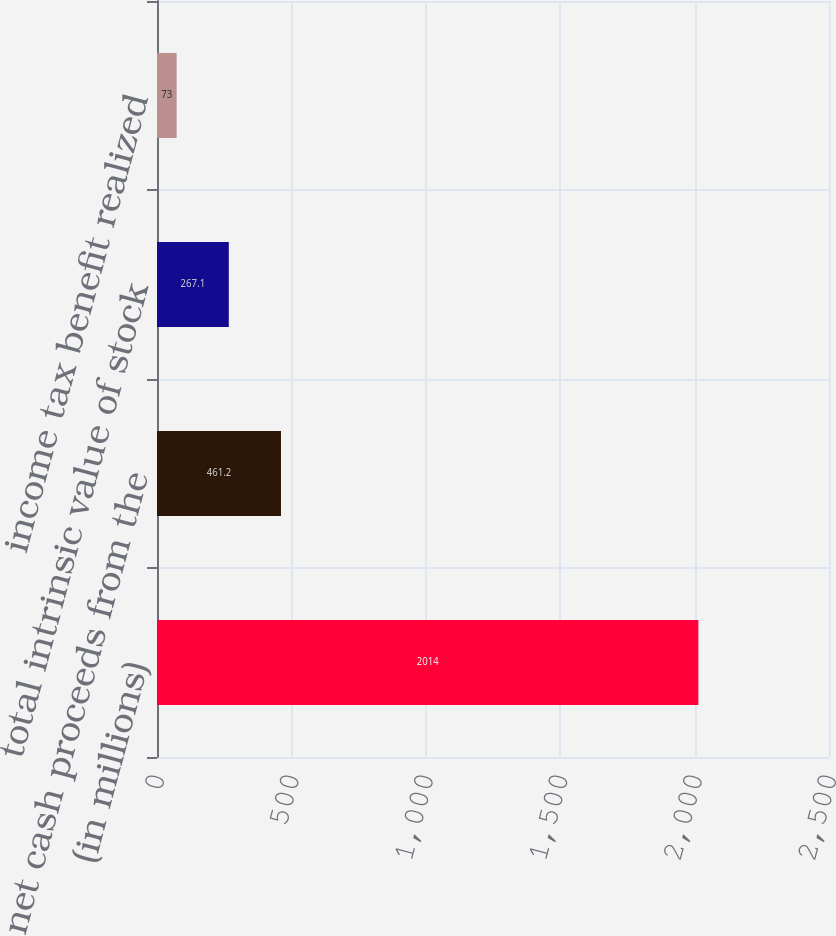Convert chart. <chart><loc_0><loc_0><loc_500><loc_500><bar_chart><fcel>(in millions)<fcel>net cash proceeds from the<fcel>total intrinsic value of stock<fcel>income tax benefit realized<nl><fcel>2014<fcel>461.2<fcel>267.1<fcel>73<nl></chart> 